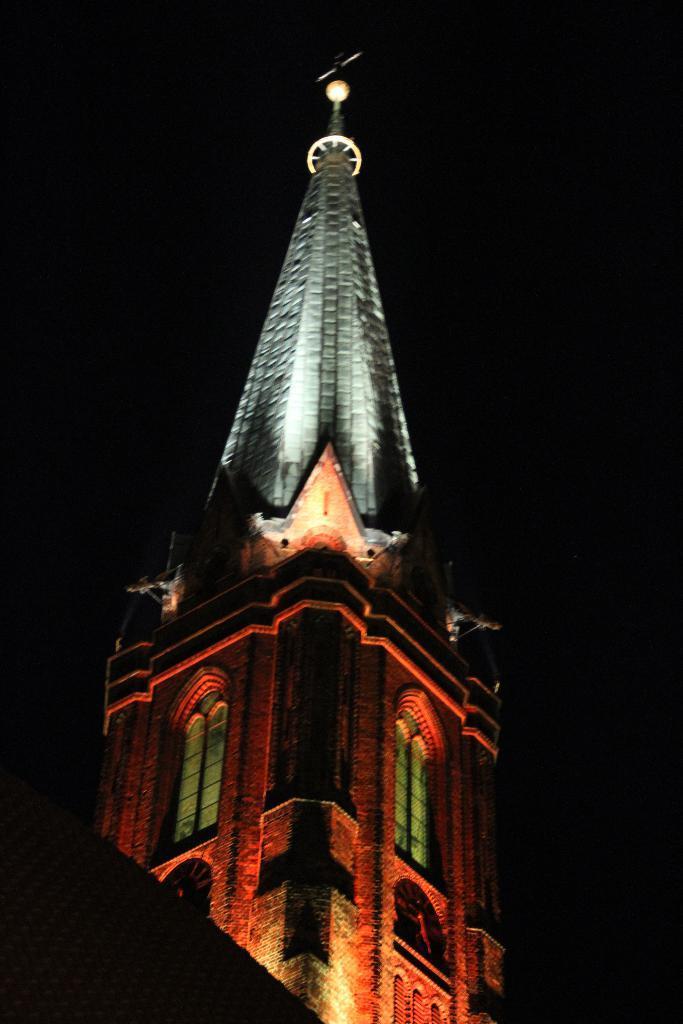In one or two sentences, can you explain what this image depicts? In this image there is a tower having windows. Background is in black color. 